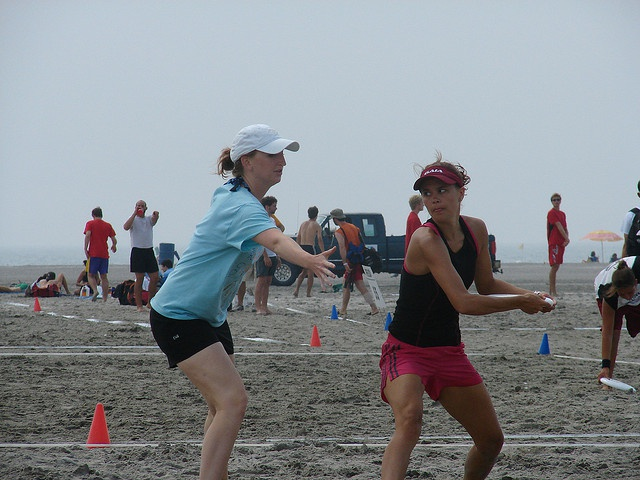Describe the objects in this image and their specific colors. I can see people in darkgray, black, maroon, and gray tones, people in darkgray, gray, black, and blue tones, people in darkgray, black, maroon, and gray tones, truck in darkgray, black, darkblue, blue, and gray tones, and people in darkgray, maroon, gray, navy, and black tones in this image. 